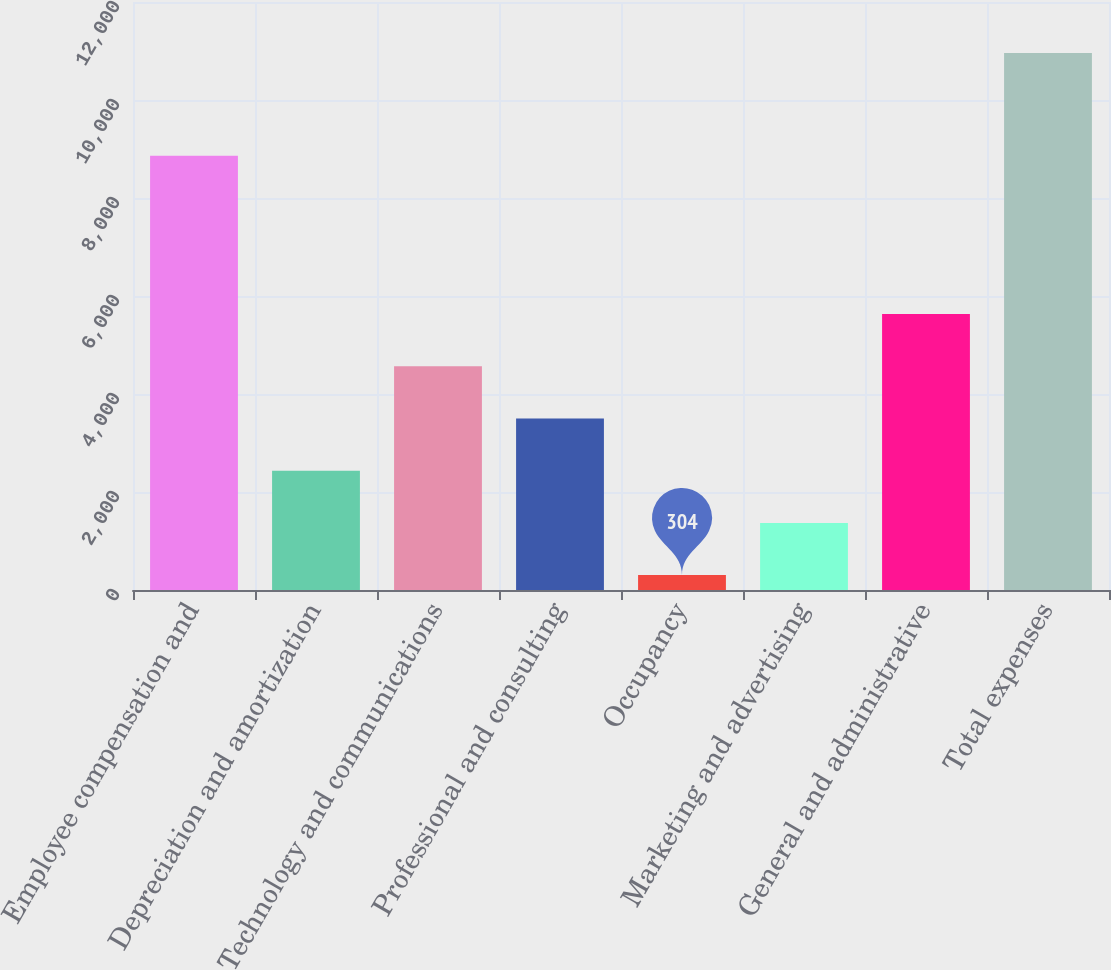<chart> <loc_0><loc_0><loc_500><loc_500><bar_chart><fcel>Employee compensation and<fcel>Depreciation and amortization<fcel>Technology and communications<fcel>Professional and consulting<fcel>Occupancy<fcel>Marketing and advertising<fcel>General and administrative<fcel>Total expenses<nl><fcel>8861<fcel>2435.2<fcel>4566.4<fcel>3500.8<fcel>304<fcel>1369.6<fcel>5632<fcel>10960<nl></chart> 